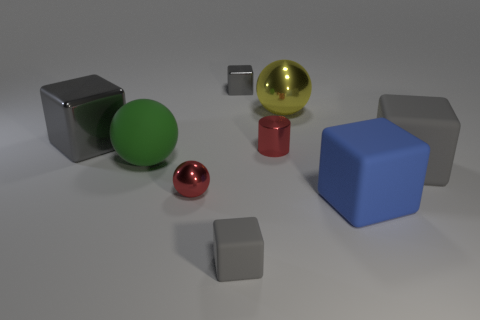Subtract all large yellow balls. How many balls are left? 2 Subtract all red balls. How many balls are left? 2 Add 1 tiny cyan blocks. How many objects exist? 10 Subtract all balls. How many objects are left? 6 Subtract all gray cubes. How many purple balls are left? 0 Subtract 1 cylinders. How many cylinders are left? 0 Subtract all yellow cylinders. Subtract all green cubes. How many cylinders are left? 1 Subtract all tiny cyan metal cylinders. Subtract all small red shiny spheres. How many objects are left? 8 Add 2 large green balls. How many large green balls are left? 3 Add 5 rubber things. How many rubber things exist? 9 